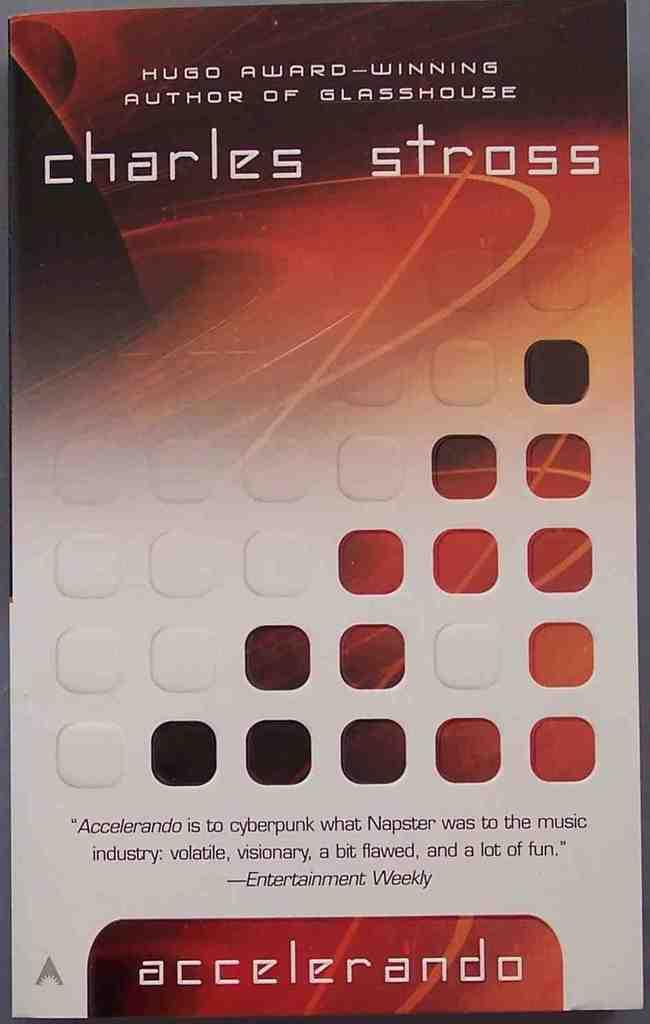<image>
Write a terse but informative summary of the picture. The book jacket says that Charles Stross won a Hugo award. 